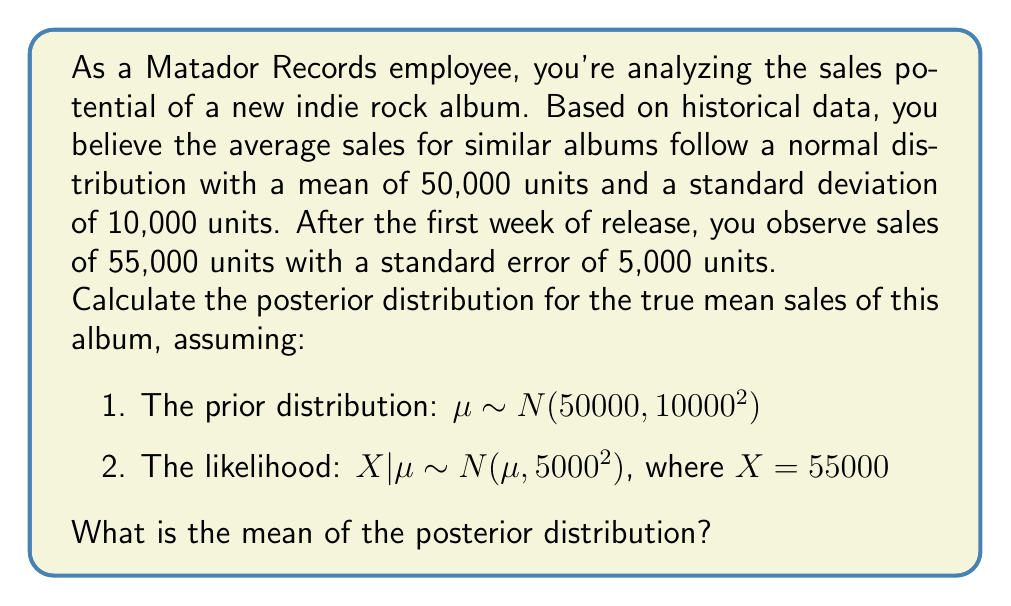Provide a solution to this math problem. To solve this Bayesian problem, we'll use the formula for updating a normal prior with normal likelihood. Let's break it down step-by-step:

1) Prior distribution: $\mu \sim N(\mu_0, \sigma_0^2)$
   Where $\mu_0 = 50000$ and $\sigma_0 = 10000$

2) Likelihood: $X|\mu \sim N(\mu, \sigma^2)$
   Where $X = 55000$ and $\sigma = 5000$

3) The posterior distribution will also be normal with parameters:

   $$\mu_{post} = \frac{\frac{\mu_0}{\sigma_0^2} + \frac{X}{\sigma^2}}{\frac{1}{\sigma_0^2} + \frac{1}{\sigma^2}}$$

   $$\sigma_{post}^2 = \frac{1}{\frac{1}{\sigma_0^2} + \frac{1}{\sigma^2}}$$

4) Let's calculate $\sigma_{post}^2$ first:

   $$\sigma_{post}^2 = \frac{1}{\frac{1}{10000^2} + \frac{1}{5000^2}} = \frac{1}{\frac{1}{100000000} + \frac{1}{25000000}} = 20000000$$

   So, $\sigma_{post} = \sqrt{20000000} \approx 4472$

5) Now, let's calculate $\mu_{post}$:

   $$\mu_{post} = \frac{\frac{50000}{100000000} + \frac{55000}{25000000}}{\frac{1}{100000000} + \frac{1}{25000000}} = \frac{0.0005 + 0.0022}{0.00000001 + 0.00000004} = \frac{0.0027}{0.00000005} = 54000$$

Therefore, the posterior distribution is $N(54000, 4472^2)$.
Answer: 54,000 units 